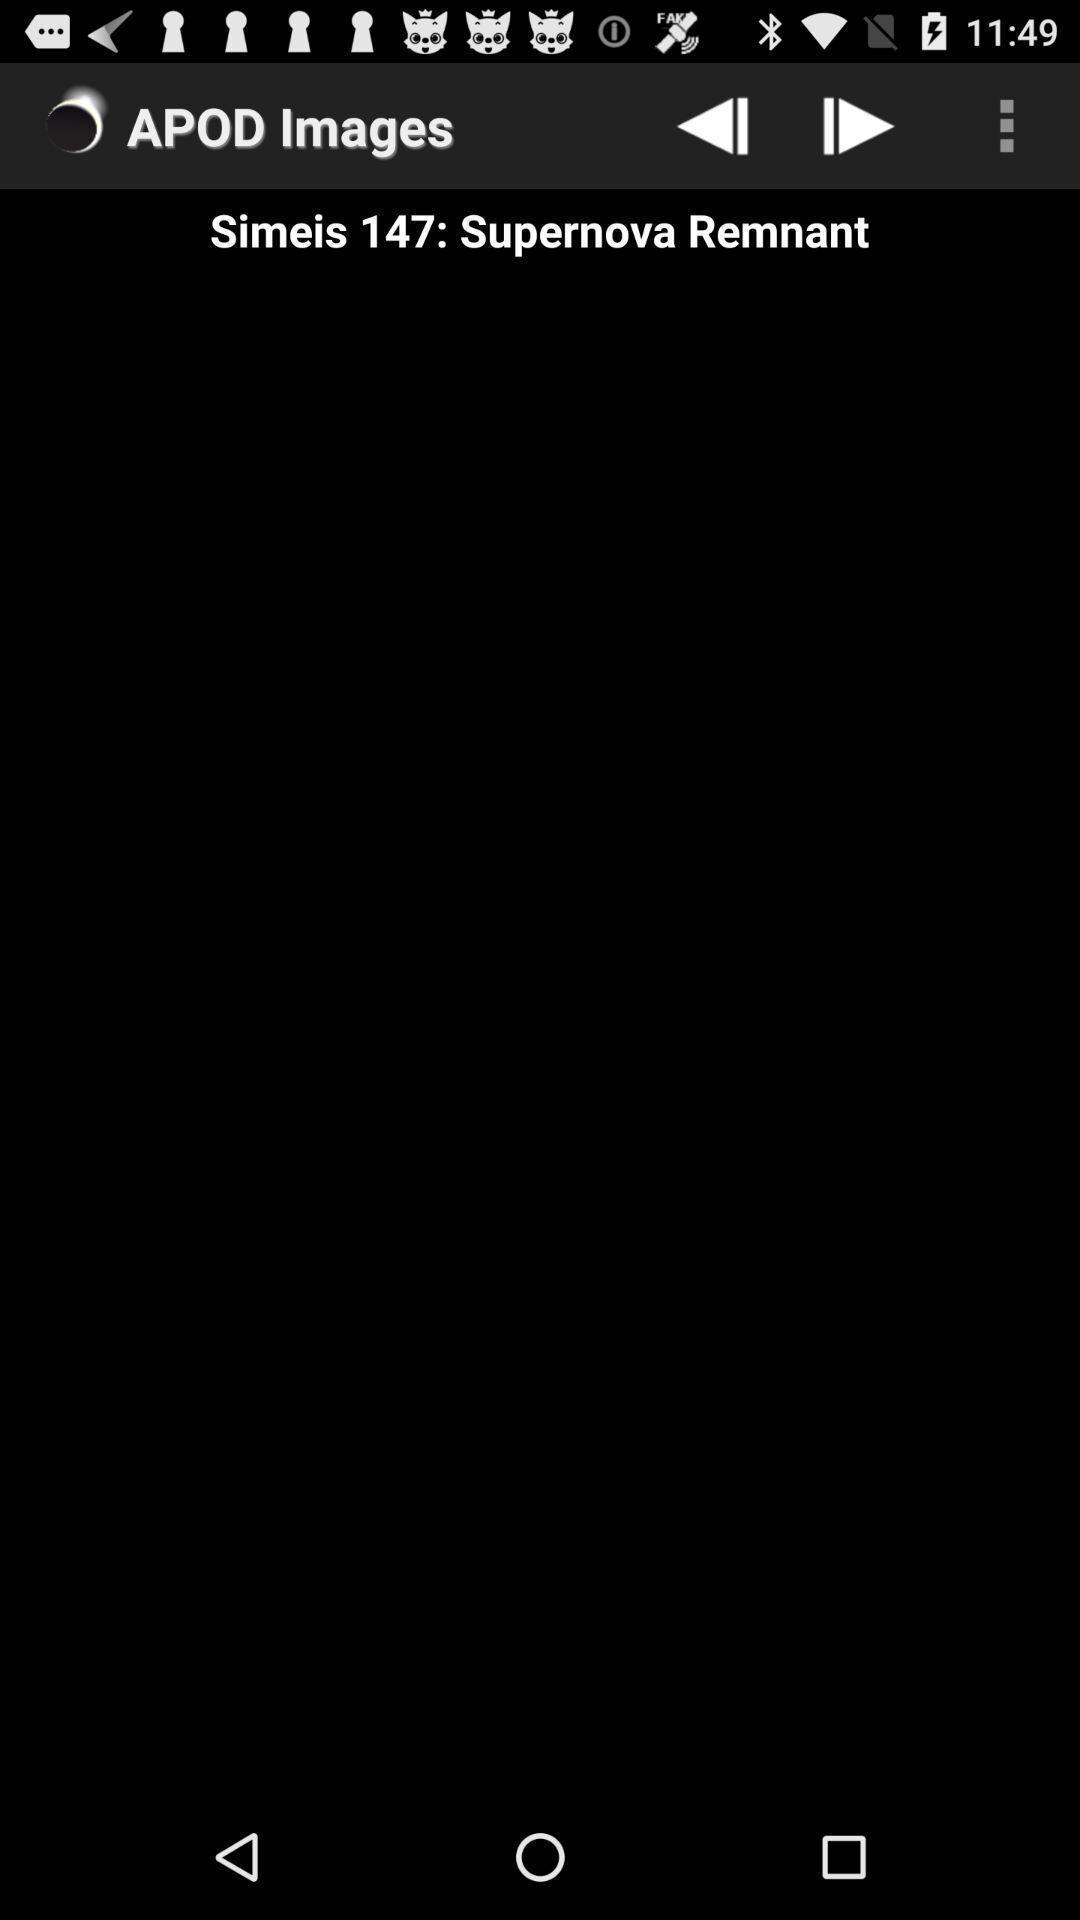Describe this image in words. Page to display related to space center. 